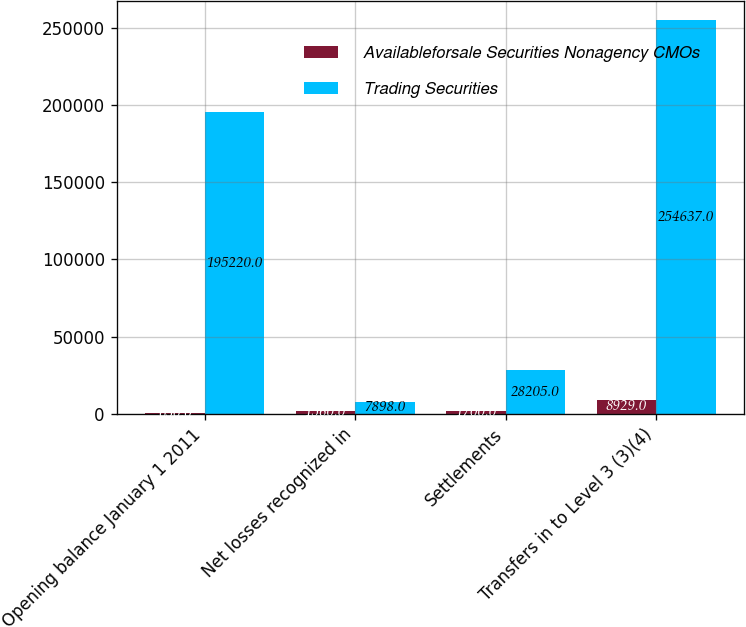Convert chart. <chart><loc_0><loc_0><loc_500><loc_500><stacked_bar_chart><ecel><fcel>Opening balance January 1 2011<fcel>Net losses recognized in<fcel>Settlements<fcel>Transfers in to Level 3 (3)(4)<nl><fcel>Availableforsale Securities Nonagency CMOs<fcel>630<fcel>1560<fcel>1700<fcel>8929<nl><fcel>Trading Securities<fcel>195220<fcel>7898<fcel>28205<fcel>254637<nl></chart> 